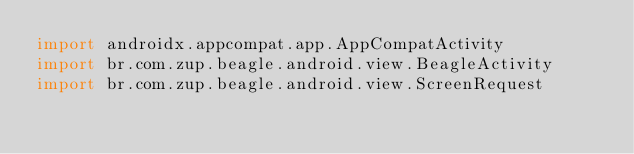<code> <loc_0><loc_0><loc_500><loc_500><_Kotlin_>import androidx.appcompat.app.AppCompatActivity
import br.com.zup.beagle.android.view.BeagleActivity
import br.com.zup.beagle.android.view.ScreenRequest</code> 